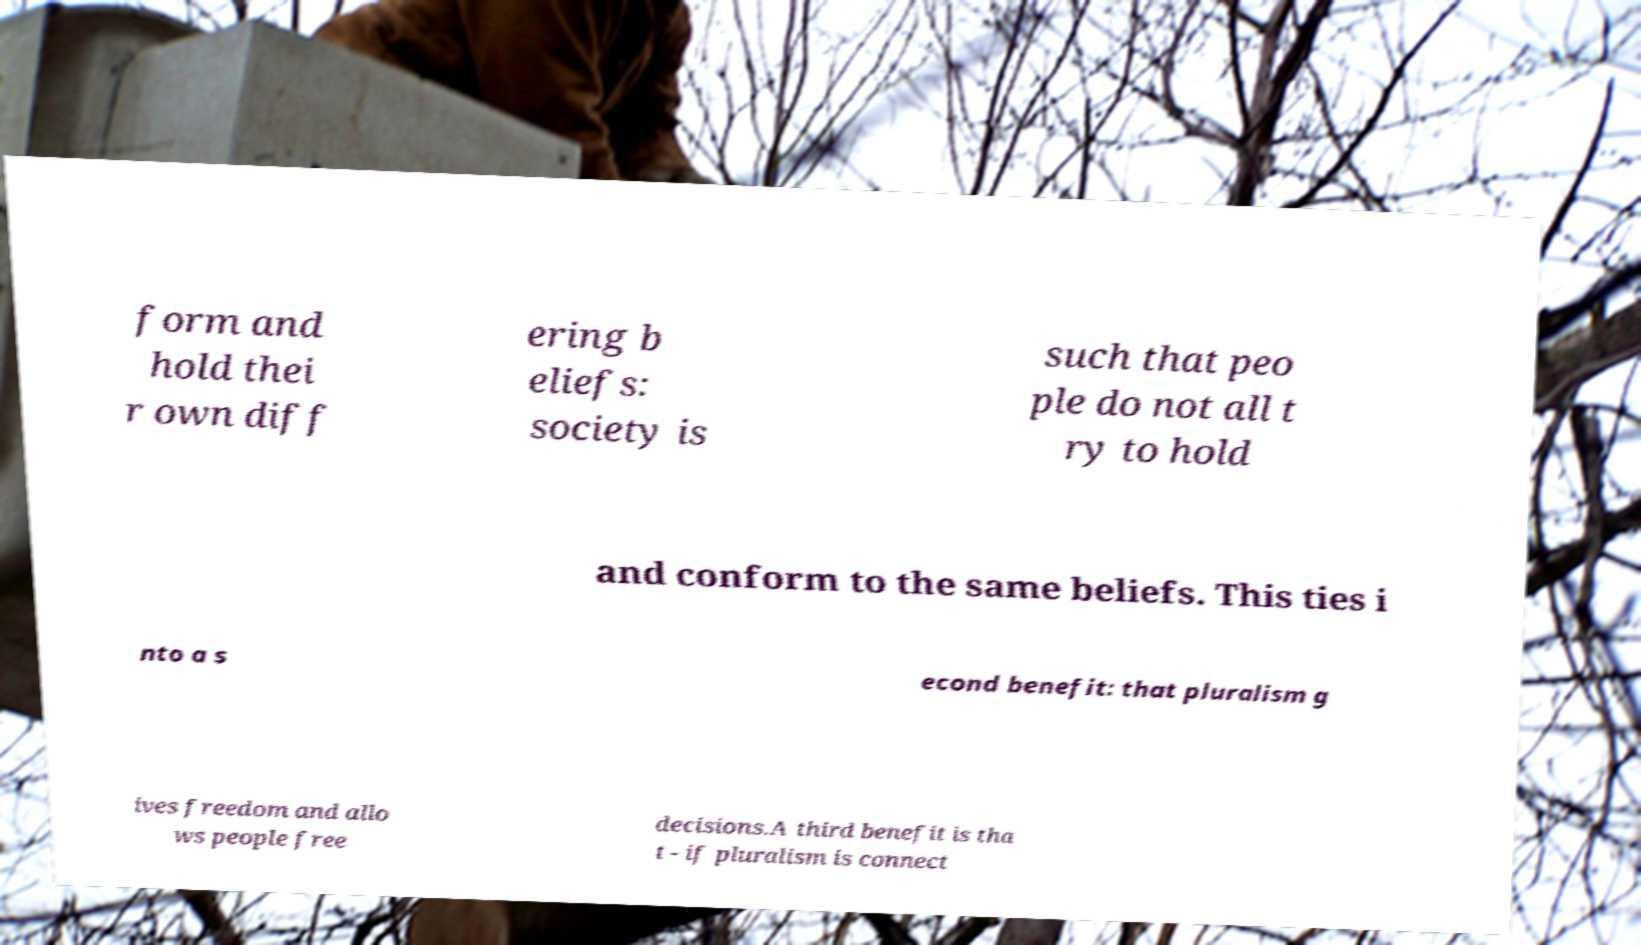There's text embedded in this image that I need extracted. Can you transcribe it verbatim? form and hold thei r own diff ering b eliefs: society is such that peo ple do not all t ry to hold and conform to the same beliefs. This ties i nto a s econd benefit: that pluralism g ives freedom and allo ws people free decisions.A third benefit is tha t - if pluralism is connect 